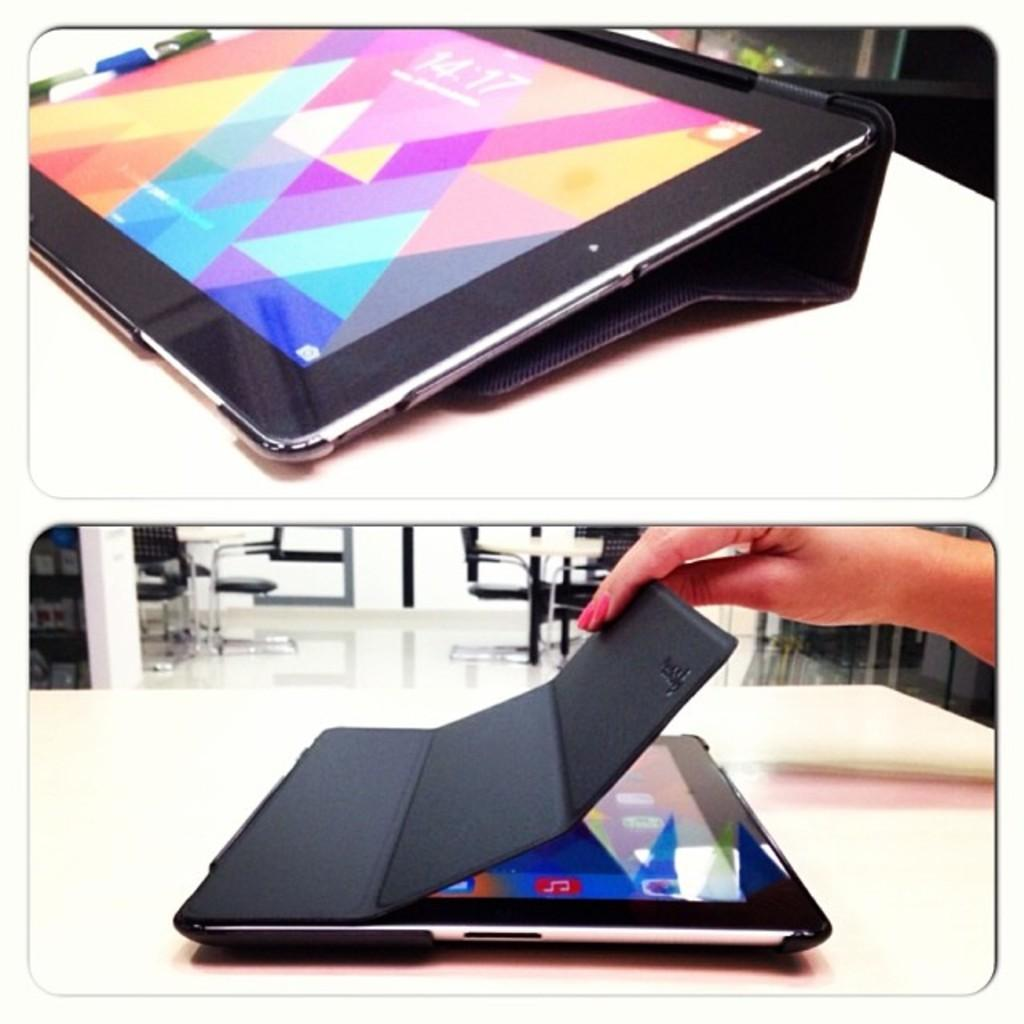What objects are present in the image that are related to photography? There are two photographs in the image. What electronic devices are visible in the image? There are two tablets in the image. Can you describe the interaction between the person and the tablets? A person's hand is touching the tablets. What type of war is depicted in the image? There is no depiction of war in the image; it features two photographs and two tablets. Can you describe the scarecrow in the image? There is no scarecrow present in the image. 